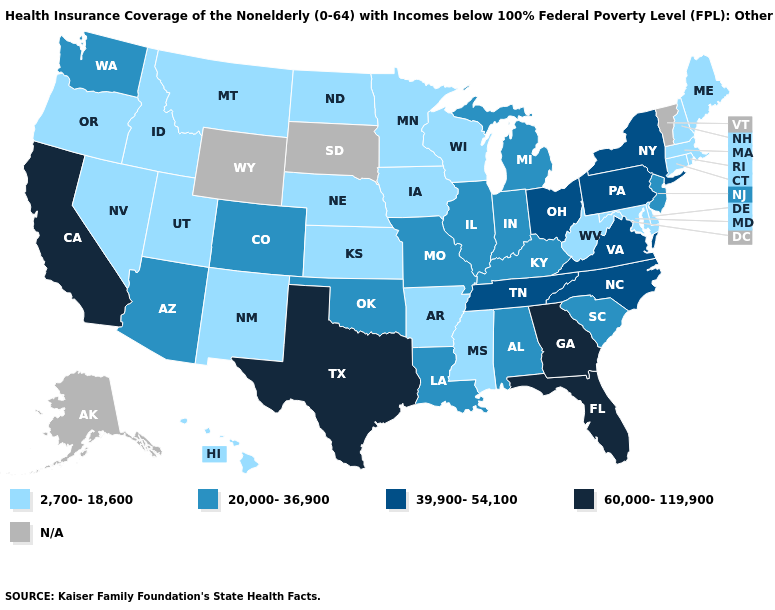Does Arizona have the highest value in the USA?
Keep it brief. No. What is the value of Wisconsin?
Short answer required. 2,700-18,600. Among the states that border Indiana , does Kentucky have the highest value?
Write a very short answer. No. Among the states that border Florida , does Georgia have the lowest value?
Concise answer only. No. What is the value of Alaska?
Give a very brief answer. N/A. What is the highest value in the MidWest ?
Short answer required. 39,900-54,100. What is the lowest value in the USA?
Write a very short answer. 2,700-18,600. Does Rhode Island have the lowest value in the Northeast?
Concise answer only. Yes. What is the lowest value in the USA?
Short answer required. 2,700-18,600. What is the highest value in the West ?
Short answer required. 60,000-119,900. Does the first symbol in the legend represent the smallest category?
Quick response, please. Yes. Among the states that border Texas , which have the lowest value?
Answer briefly. Arkansas, New Mexico. What is the value of Arkansas?
Answer briefly. 2,700-18,600. Which states have the lowest value in the USA?
Be succinct. Arkansas, Connecticut, Delaware, Hawaii, Idaho, Iowa, Kansas, Maine, Maryland, Massachusetts, Minnesota, Mississippi, Montana, Nebraska, Nevada, New Hampshire, New Mexico, North Dakota, Oregon, Rhode Island, Utah, West Virginia, Wisconsin. 